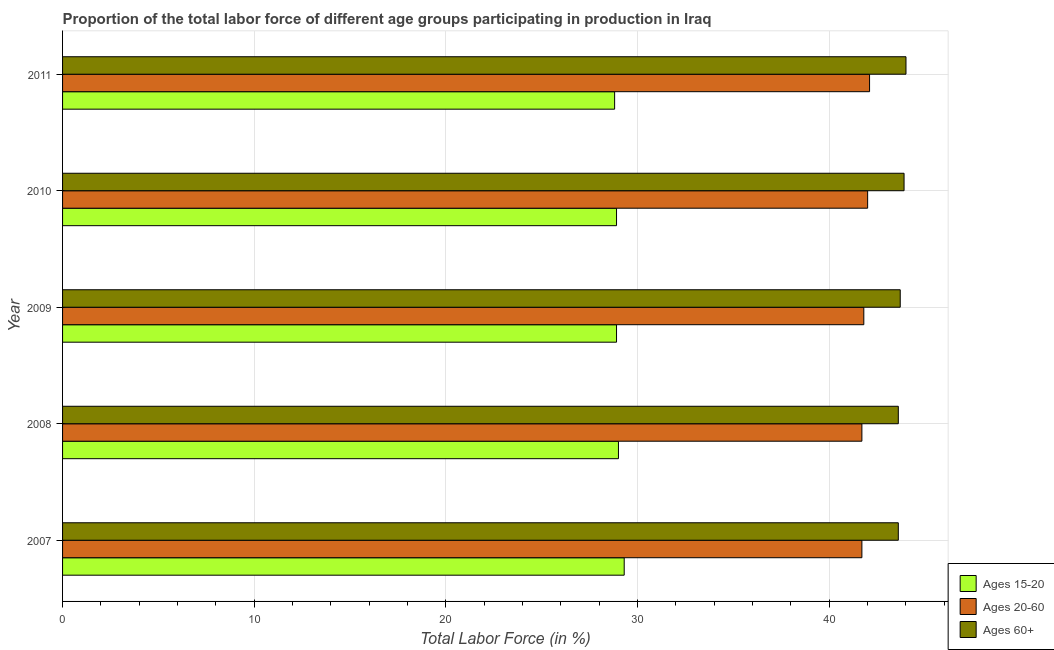How many different coloured bars are there?
Ensure brevity in your answer.  3. How many bars are there on the 2nd tick from the top?
Your answer should be very brief. 3. How many bars are there on the 5th tick from the bottom?
Your answer should be very brief. 3. In how many cases, is the number of bars for a given year not equal to the number of legend labels?
Give a very brief answer. 0. What is the percentage of labor force above age 60 in 2008?
Offer a very short reply. 43.6. Across all years, what is the maximum percentage of labor force within the age group 20-60?
Provide a succinct answer. 42.1. Across all years, what is the minimum percentage of labor force within the age group 20-60?
Give a very brief answer. 41.7. In which year was the percentage of labor force within the age group 15-20 maximum?
Ensure brevity in your answer.  2007. What is the total percentage of labor force above age 60 in the graph?
Your answer should be compact. 218.8. What is the difference between the percentage of labor force within the age group 20-60 in 2010 and that in 2011?
Keep it short and to the point. -0.1. What is the difference between the percentage of labor force within the age group 15-20 in 2008 and the percentage of labor force within the age group 20-60 in 2011?
Provide a short and direct response. -13.1. What is the average percentage of labor force within the age group 15-20 per year?
Ensure brevity in your answer.  28.98. In the year 2009, what is the difference between the percentage of labor force within the age group 20-60 and percentage of labor force within the age group 15-20?
Offer a terse response. 12.9. In how many years, is the percentage of labor force within the age group 20-60 greater than 22 %?
Give a very brief answer. 5. In how many years, is the percentage of labor force above age 60 greater than the average percentage of labor force above age 60 taken over all years?
Provide a succinct answer. 2. What does the 2nd bar from the top in 2009 represents?
Provide a succinct answer. Ages 20-60. What does the 2nd bar from the bottom in 2007 represents?
Offer a very short reply. Ages 20-60. Is it the case that in every year, the sum of the percentage of labor force within the age group 15-20 and percentage of labor force within the age group 20-60 is greater than the percentage of labor force above age 60?
Your response must be concise. Yes. How many bars are there?
Give a very brief answer. 15. Are all the bars in the graph horizontal?
Keep it short and to the point. Yes. Are the values on the major ticks of X-axis written in scientific E-notation?
Your response must be concise. No. Does the graph contain grids?
Ensure brevity in your answer.  Yes. How many legend labels are there?
Ensure brevity in your answer.  3. How are the legend labels stacked?
Ensure brevity in your answer.  Vertical. What is the title of the graph?
Provide a succinct answer. Proportion of the total labor force of different age groups participating in production in Iraq. What is the label or title of the Y-axis?
Your response must be concise. Year. What is the Total Labor Force (in %) in Ages 15-20 in 2007?
Offer a very short reply. 29.3. What is the Total Labor Force (in %) of Ages 20-60 in 2007?
Your answer should be compact. 41.7. What is the Total Labor Force (in %) of Ages 60+ in 2007?
Give a very brief answer. 43.6. What is the Total Labor Force (in %) in Ages 20-60 in 2008?
Offer a very short reply. 41.7. What is the Total Labor Force (in %) of Ages 60+ in 2008?
Offer a terse response. 43.6. What is the Total Labor Force (in %) of Ages 15-20 in 2009?
Give a very brief answer. 28.9. What is the Total Labor Force (in %) in Ages 20-60 in 2009?
Offer a terse response. 41.8. What is the Total Labor Force (in %) in Ages 60+ in 2009?
Offer a terse response. 43.7. What is the Total Labor Force (in %) in Ages 15-20 in 2010?
Offer a terse response. 28.9. What is the Total Labor Force (in %) of Ages 60+ in 2010?
Give a very brief answer. 43.9. What is the Total Labor Force (in %) of Ages 15-20 in 2011?
Your answer should be compact. 28.8. What is the Total Labor Force (in %) in Ages 20-60 in 2011?
Your response must be concise. 42.1. What is the Total Labor Force (in %) of Ages 60+ in 2011?
Keep it short and to the point. 44. Across all years, what is the maximum Total Labor Force (in %) of Ages 15-20?
Provide a short and direct response. 29.3. Across all years, what is the maximum Total Labor Force (in %) in Ages 20-60?
Your answer should be very brief. 42.1. Across all years, what is the maximum Total Labor Force (in %) in Ages 60+?
Give a very brief answer. 44. Across all years, what is the minimum Total Labor Force (in %) in Ages 15-20?
Provide a succinct answer. 28.8. Across all years, what is the minimum Total Labor Force (in %) in Ages 20-60?
Offer a very short reply. 41.7. Across all years, what is the minimum Total Labor Force (in %) in Ages 60+?
Your answer should be very brief. 43.6. What is the total Total Labor Force (in %) of Ages 15-20 in the graph?
Offer a terse response. 144.9. What is the total Total Labor Force (in %) in Ages 20-60 in the graph?
Give a very brief answer. 209.3. What is the total Total Labor Force (in %) of Ages 60+ in the graph?
Keep it short and to the point. 218.8. What is the difference between the Total Labor Force (in %) in Ages 15-20 in 2007 and that in 2008?
Give a very brief answer. 0.3. What is the difference between the Total Labor Force (in %) in Ages 20-60 in 2007 and that in 2008?
Your response must be concise. 0. What is the difference between the Total Labor Force (in %) of Ages 15-20 in 2007 and that in 2009?
Ensure brevity in your answer.  0.4. What is the difference between the Total Labor Force (in %) of Ages 20-60 in 2007 and that in 2009?
Keep it short and to the point. -0.1. What is the difference between the Total Labor Force (in %) of Ages 60+ in 2007 and that in 2009?
Your response must be concise. -0.1. What is the difference between the Total Labor Force (in %) in Ages 20-60 in 2007 and that in 2010?
Your answer should be compact. -0.3. What is the difference between the Total Labor Force (in %) of Ages 60+ in 2007 and that in 2011?
Give a very brief answer. -0.4. What is the difference between the Total Labor Force (in %) of Ages 60+ in 2008 and that in 2009?
Your answer should be compact. -0.1. What is the difference between the Total Labor Force (in %) in Ages 60+ in 2008 and that in 2010?
Offer a terse response. -0.3. What is the difference between the Total Labor Force (in %) in Ages 20-60 in 2008 and that in 2011?
Offer a terse response. -0.4. What is the difference between the Total Labor Force (in %) in Ages 60+ in 2008 and that in 2011?
Offer a terse response. -0.4. What is the difference between the Total Labor Force (in %) of Ages 15-20 in 2009 and that in 2010?
Provide a succinct answer. 0. What is the difference between the Total Labor Force (in %) in Ages 20-60 in 2009 and that in 2010?
Offer a very short reply. -0.2. What is the difference between the Total Labor Force (in %) of Ages 15-20 in 2007 and the Total Labor Force (in %) of Ages 20-60 in 2008?
Provide a short and direct response. -12.4. What is the difference between the Total Labor Force (in %) of Ages 15-20 in 2007 and the Total Labor Force (in %) of Ages 60+ in 2008?
Make the answer very short. -14.3. What is the difference between the Total Labor Force (in %) of Ages 20-60 in 2007 and the Total Labor Force (in %) of Ages 60+ in 2008?
Provide a succinct answer. -1.9. What is the difference between the Total Labor Force (in %) in Ages 15-20 in 2007 and the Total Labor Force (in %) in Ages 20-60 in 2009?
Keep it short and to the point. -12.5. What is the difference between the Total Labor Force (in %) in Ages 15-20 in 2007 and the Total Labor Force (in %) in Ages 60+ in 2009?
Make the answer very short. -14.4. What is the difference between the Total Labor Force (in %) in Ages 20-60 in 2007 and the Total Labor Force (in %) in Ages 60+ in 2009?
Your answer should be very brief. -2. What is the difference between the Total Labor Force (in %) of Ages 15-20 in 2007 and the Total Labor Force (in %) of Ages 20-60 in 2010?
Offer a very short reply. -12.7. What is the difference between the Total Labor Force (in %) in Ages 15-20 in 2007 and the Total Labor Force (in %) in Ages 60+ in 2010?
Offer a very short reply. -14.6. What is the difference between the Total Labor Force (in %) of Ages 20-60 in 2007 and the Total Labor Force (in %) of Ages 60+ in 2010?
Your answer should be very brief. -2.2. What is the difference between the Total Labor Force (in %) in Ages 15-20 in 2007 and the Total Labor Force (in %) in Ages 20-60 in 2011?
Provide a succinct answer. -12.8. What is the difference between the Total Labor Force (in %) in Ages 15-20 in 2007 and the Total Labor Force (in %) in Ages 60+ in 2011?
Your answer should be very brief. -14.7. What is the difference between the Total Labor Force (in %) in Ages 15-20 in 2008 and the Total Labor Force (in %) in Ages 60+ in 2009?
Make the answer very short. -14.7. What is the difference between the Total Labor Force (in %) of Ages 20-60 in 2008 and the Total Labor Force (in %) of Ages 60+ in 2009?
Give a very brief answer. -2. What is the difference between the Total Labor Force (in %) of Ages 15-20 in 2008 and the Total Labor Force (in %) of Ages 60+ in 2010?
Make the answer very short. -14.9. What is the difference between the Total Labor Force (in %) in Ages 15-20 in 2008 and the Total Labor Force (in %) in Ages 60+ in 2011?
Offer a very short reply. -15. What is the difference between the Total Labor Force (in %) of Ages 20-60 in 2008 and the Total Labor Force (in %) of Ages 60+ in 2011?
Your answer should be very brief. -2.3. What is the difference between the Total Labor Force (in %) in Ages 15-20 in 2009 and the Total Labor Force (in %) in Ages 20-60 in 2010?
Keep it short and to the point. -13.1. What is the difference between the Total Labor Force (in %) in Ages 15-20 in 2009 and the Total Labor Force (in %) in Ages 60+ in 2010?
Your answer should be compact. -15. What is the difference between the Total Labor Force (in %) of Ages 20-60 in 2009 and the Total Labor Force (in %) of Ages 60+ in 2010?
Keep it short and to the point. -2.1. What is the difference between the Total Labor Force (in %) of Ages 15-20 in 2009 and the Total Labor Force (in %) of Ages 20-60 in 2011?
Your response must be concise. -13.2. What is the difference between the Total Labor Force (in %) of Ages 15-20 in 2009 and the Total Labor Force (in %) of Ages 60+ in 2011?
Keep it short and to the point. -15.1. What is the difference between the Total Labor Force (in %) in Ages 15-20 in 2010 and the Total Labor Force (in %) in Ages 20-60 in 2011?
Keep it short and to the point. -13.2. What is the difference between the Total Labor Force (in %) of Ages 15-20 in 2010 and the Total Labor Force (in %) of Ages 60+ in 2011?
Provide a succinct answer. -15.1. What is the average Total Labor Force (in %) in Ages 15-20 per year?
Keep it short and to the point. 28.98. What is the average Total Labor Force (in %) in Ages 20-60 per year?
Your response must be concise. 41.86. What is the average Total Labor Force (in %) in Ages 60+ per year?
Your answer should be compact. 43.76. In the year 2007, what is the difference between the Total Labor Force (in %) in Ages 15-20 and Total Labor Force (in %) in Ages 60+?
Keep it short and to the point. -14.3. In the year 2008, what is the difference between the Total Labor Force (in %) in Ages 15-20 and Total Labor Force (in %) in Ages 20-60?
Provide a succinct answer. -12.7. In the year 2008, what is the difference between the Total Labor Force (in %) in Ages 15-20 and Total Labor Force (in %) in Ages 60+?
Your answer should be compact. -14.6. In the year 2008, what is the difference between the Total Labor Force (in %) in Ages 20-60 and Total Labor Force (in %) in Ages 60+?
Your answer should be compact. -1.9. In the year 2009, what is the difference between the Total Labor Force (in %) of Ages 15-20 and Total Labor Force (in %) of Ages 20-60?
Your answer should be very brief. -12.9. In the year 2009, what is the difference between the Total Labor Force (in %) of Ages 15-20 and Total Labor Force (in %) of Ages 60+?
Provide a succinct answer. -14.8. In the year 2010, what is the difference between the Total Labor Force (in %) in Ages 15-20 and Total Labor Force (in %) in Ages 20-60?
Offer a very short reply. -13.1. In the year 2010, what is the difference between the Total Labor Force (in %) of Ages 20-60 and Total Labor Force (in %) of Ages 60+?
Give a very brief answer. -1.9. In the year 2011, what is the difference between the Total Labor Force (in %) in Ages 15-20 and Total Labor Force (in %) in Ages 60+?
Your answer should be compact. -15.2. What is the ratio of the Total Labor Force (in %) in Ages 15-20 in 2007 to that in 2008?
Give a very brief answer. 1.01. What is the ratio of the Total Labor Force (in %) of Ages 15-20 in 2007 to that in 2009?
Your answer should be compact. 1.01. What is the ratio of the Total Labor Force (in %) of Ages 20-60 in 2007 to that in 2009?
Offer a terse response. 1. What is the ratio of the Total Labor Force (in %) of Ages 15-20 in 2007 to that in 2010?
Give a very brief answer. 1.01. What is the ratio of the Total Labor Force (in %) in Ages 20-60 in 2007 to that in 2010?
Ensure brevity in your answer.  0.99. What is the ratio of the Total Labor Force (in %) in Ages 60+ in 2007 to that in 2010?
Offer a very short reply. 0.99. What is the ratio of the Total Labor Force (in %) of Ages 15-20 in 2007 to that in 2011?
Keep it short and to the point. 1.02. What is the ratio of the Total Labor Force (in %) in Ages 20-60 in 2007 to that in 2011?
Provide a succinct answer. 0.99. What is the ratio of the Total Labor Force (in %) of Ages 60+ in 2007 to that in 2011?
Keep it short and to the point. 0.99. What is the ratio of the Total Labor Force (in %) in Ages 15-20 in 2008 to that in 2009?
Provide a short and direct response. 1. What is the ratio of the Total Labor Force (in %) in Ages 20-60 in 2008 to that in 2009?
Ensure brevity in your answer.  1. What is the ratio of the Total Labor Force (in %) in Ages 20-60 in 2008 to that in 2010?
Ensure brevity in your answer.  0.99. What is the ratio of the Total Labor Force (in %) of Ages 15-20 in 2008 to that in 2011?
Provide a short and direct response. 1.01. What is the ratio of the Total Labor Force (in %) in Ages 20-60 in 2008 to that in 2011?
Ensure brevity in your answer.  0.99. What is the ratio of the Total Labor Force (in %) of Ages 60+ in 2008 to that in 2011?
Keep it short and to the point. 0.99. What is the ratio of the Total Labor Force (in %) of Ages 15-20 in 2009 to that in 2011?
Give a very brief answer. 1. What is the ratio of the Total Labor Force (in %) in Ages 20-60 in 2009 to that in 2011?
Offer a very short reply. 0.99. What is the ratio of the Total Labor Force (in %) of Ages 15-20 in 2010 to that in 2011?
Offer a very short reply. 1. What is the difference between the highest and the second highest Total Labor Force (in %) of Ages 60+?
Ensure brevity in your answer.  0.1. 